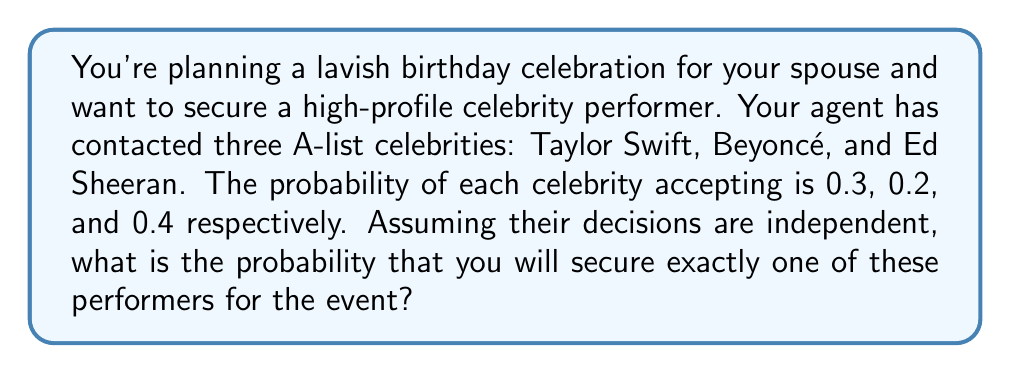Could you help me with this problem? Let's approach this step-by-step using the concept of probability for independent events:

1) Let's define our events:
   T: Taylor Swift accepts
   B: Beyoncé accepts
   E: Ed Sheeran accepts

2) We're looking for the probability of exactly one celebrity accepting. This can happen in three ways:
   - Only Taylor accepts
   - Only Beyoncé accepts
   - Only Ed accepts

3) Let's calculate each of these probabilities:

   P(Only Taylor) = P(T) * P(not B) * P(not E)
   = 0.3 * (1-0.2) * (1-0.4) = 0.3 * 0.8 * 0.6 = 0.144

   P(Only Beyoncé) = P(not T) * P(B) * P(not E)
   = (1-0.3) * 0.2 * (1-0.4) = 0.7 * 0.2 * 0.6 = 0.084

   P(Only Ed) = P(not T) * P(not B) * P(E)
   = (1-0.3) * (1-0.2) * 0.4 = 0.7 * 0.8 * 0.4 = 0.224

4) The probability of exactly one celebrity accepting is the sum of these probabilities:

   $$P(\text{Exactly one}) = P(\text{Only Taylor}) + P(\text{Only Beyoncé}) + P(\text{Only Ed})$$
   $$= 0.144 + 0.084 + 0.224 = 0.452$$

Therefore, the probability of securing exactly one of these performers for the event is 0.452 or 45.2%.
Answer: 0.452 